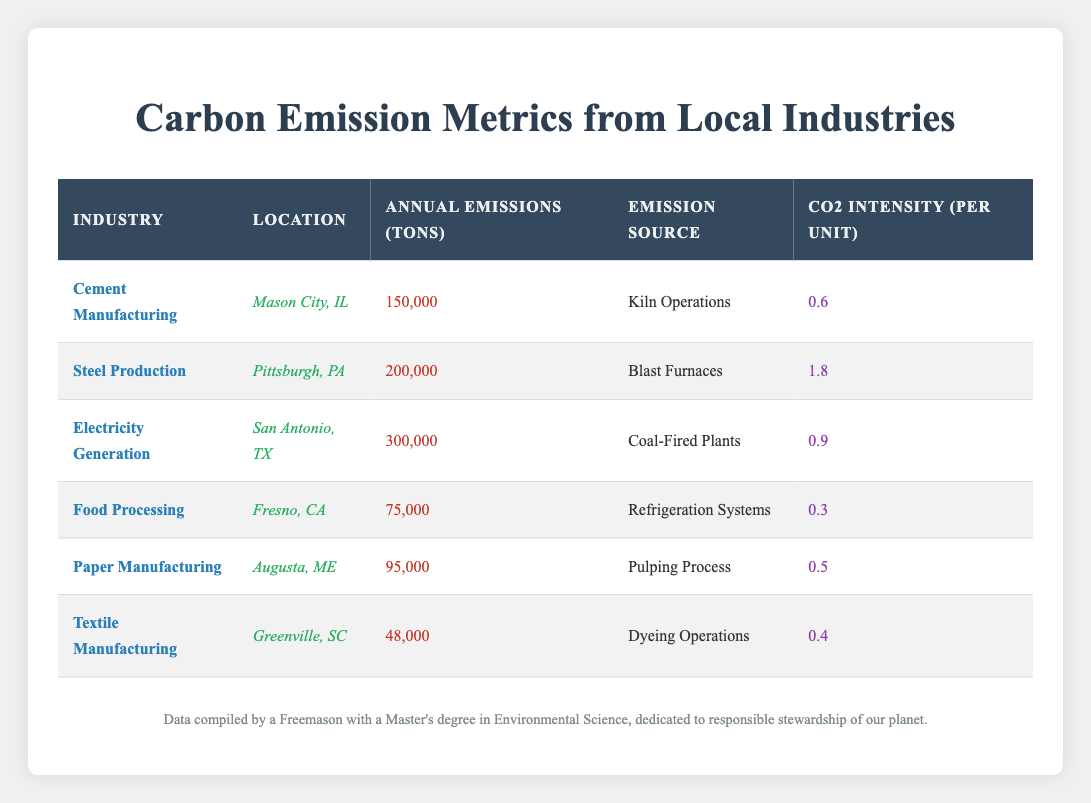What is the annual emissions for the Cement Manufacturing industry? Referring to the table, the annual emissions for Cement Manufacturing is listed as 150,000 tons.
Answer: 150,000 tons Which industry has the highest CO2 intensity per unit? Looking at the CO2 intensity column, the Steel Production industry shows the highest value of 1.8 per unit.
Answer: Steel Production What is the total annual emissions from the Electricity Generation and Steel Production industries combined? The annual emissions for Electricity Generation is 300,000 tons and for Steel Production is 200,000 tons. Adding these gives 300,000 + 200,000 = 500,000 tons.
Answer: 500,000 tons Is the total emissions from Food Processing greater than that of Textile Manufacturing? The annual emissions for Food Processing is 75,000 tons, while for Textile Manufacturing it is 48,000 tons. Since 75,000 is greater than 48,000, the statement is true.
Answer: Yes What are the average CO2 intensity values for Paper Manufacturing and Food Processing combined? The CO2 intensity for Paper Manufacturing is 0.5, and for Food Processing, it's 0.3. The average is (0.5 + 0.3) / 2 = 0.4.
Answer: 0.4 